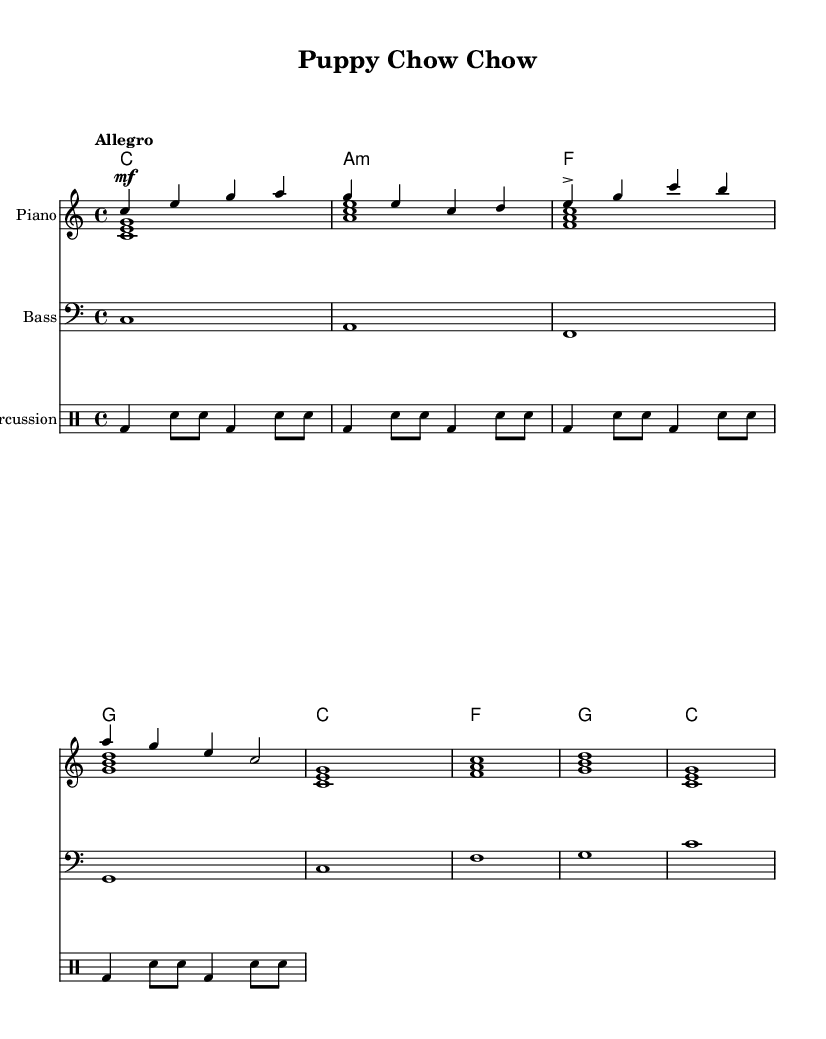What is the key signature of this music? The key signature is set at C major, which indicates there are no sharps or flats; this can be seen at the beginning of the staff.
Answer: C major What is the time signature of this music? The time signature is specified as 4/4, which is located at the beginning of the score. This means there are four beats in each measure, with the quarter note receiving one beat.
Answer: 4/4 What is the tempo marking for this piece? The tempo marking indicates "Allegro," which suggests a fast and cheerful speed for performing the piece, placed above the staff at the beginning.
Answer: Allegro How many measures are there in the melody section? Counting the measures in the melody line reveals there are four distinct measures, as separated by the vertical lines on the staff.
Answer: 4 What is the ending note of the melody? The melody section concludes with a 'c' note at the end of the fourth measure; this can be identified as the last note on the staff in that section.
Answer: c Which instrument is indicated for the harmonies? The harmonies are indicated for the piano, as specified at the top of the staff where the instrument name is displayed.
Answer: Piano How many times does the bass play in conjunction with the melody? The bass section plays in sync with the melody across the same four measures, outlining the harmonic structure of each measure.
Answer: 4 